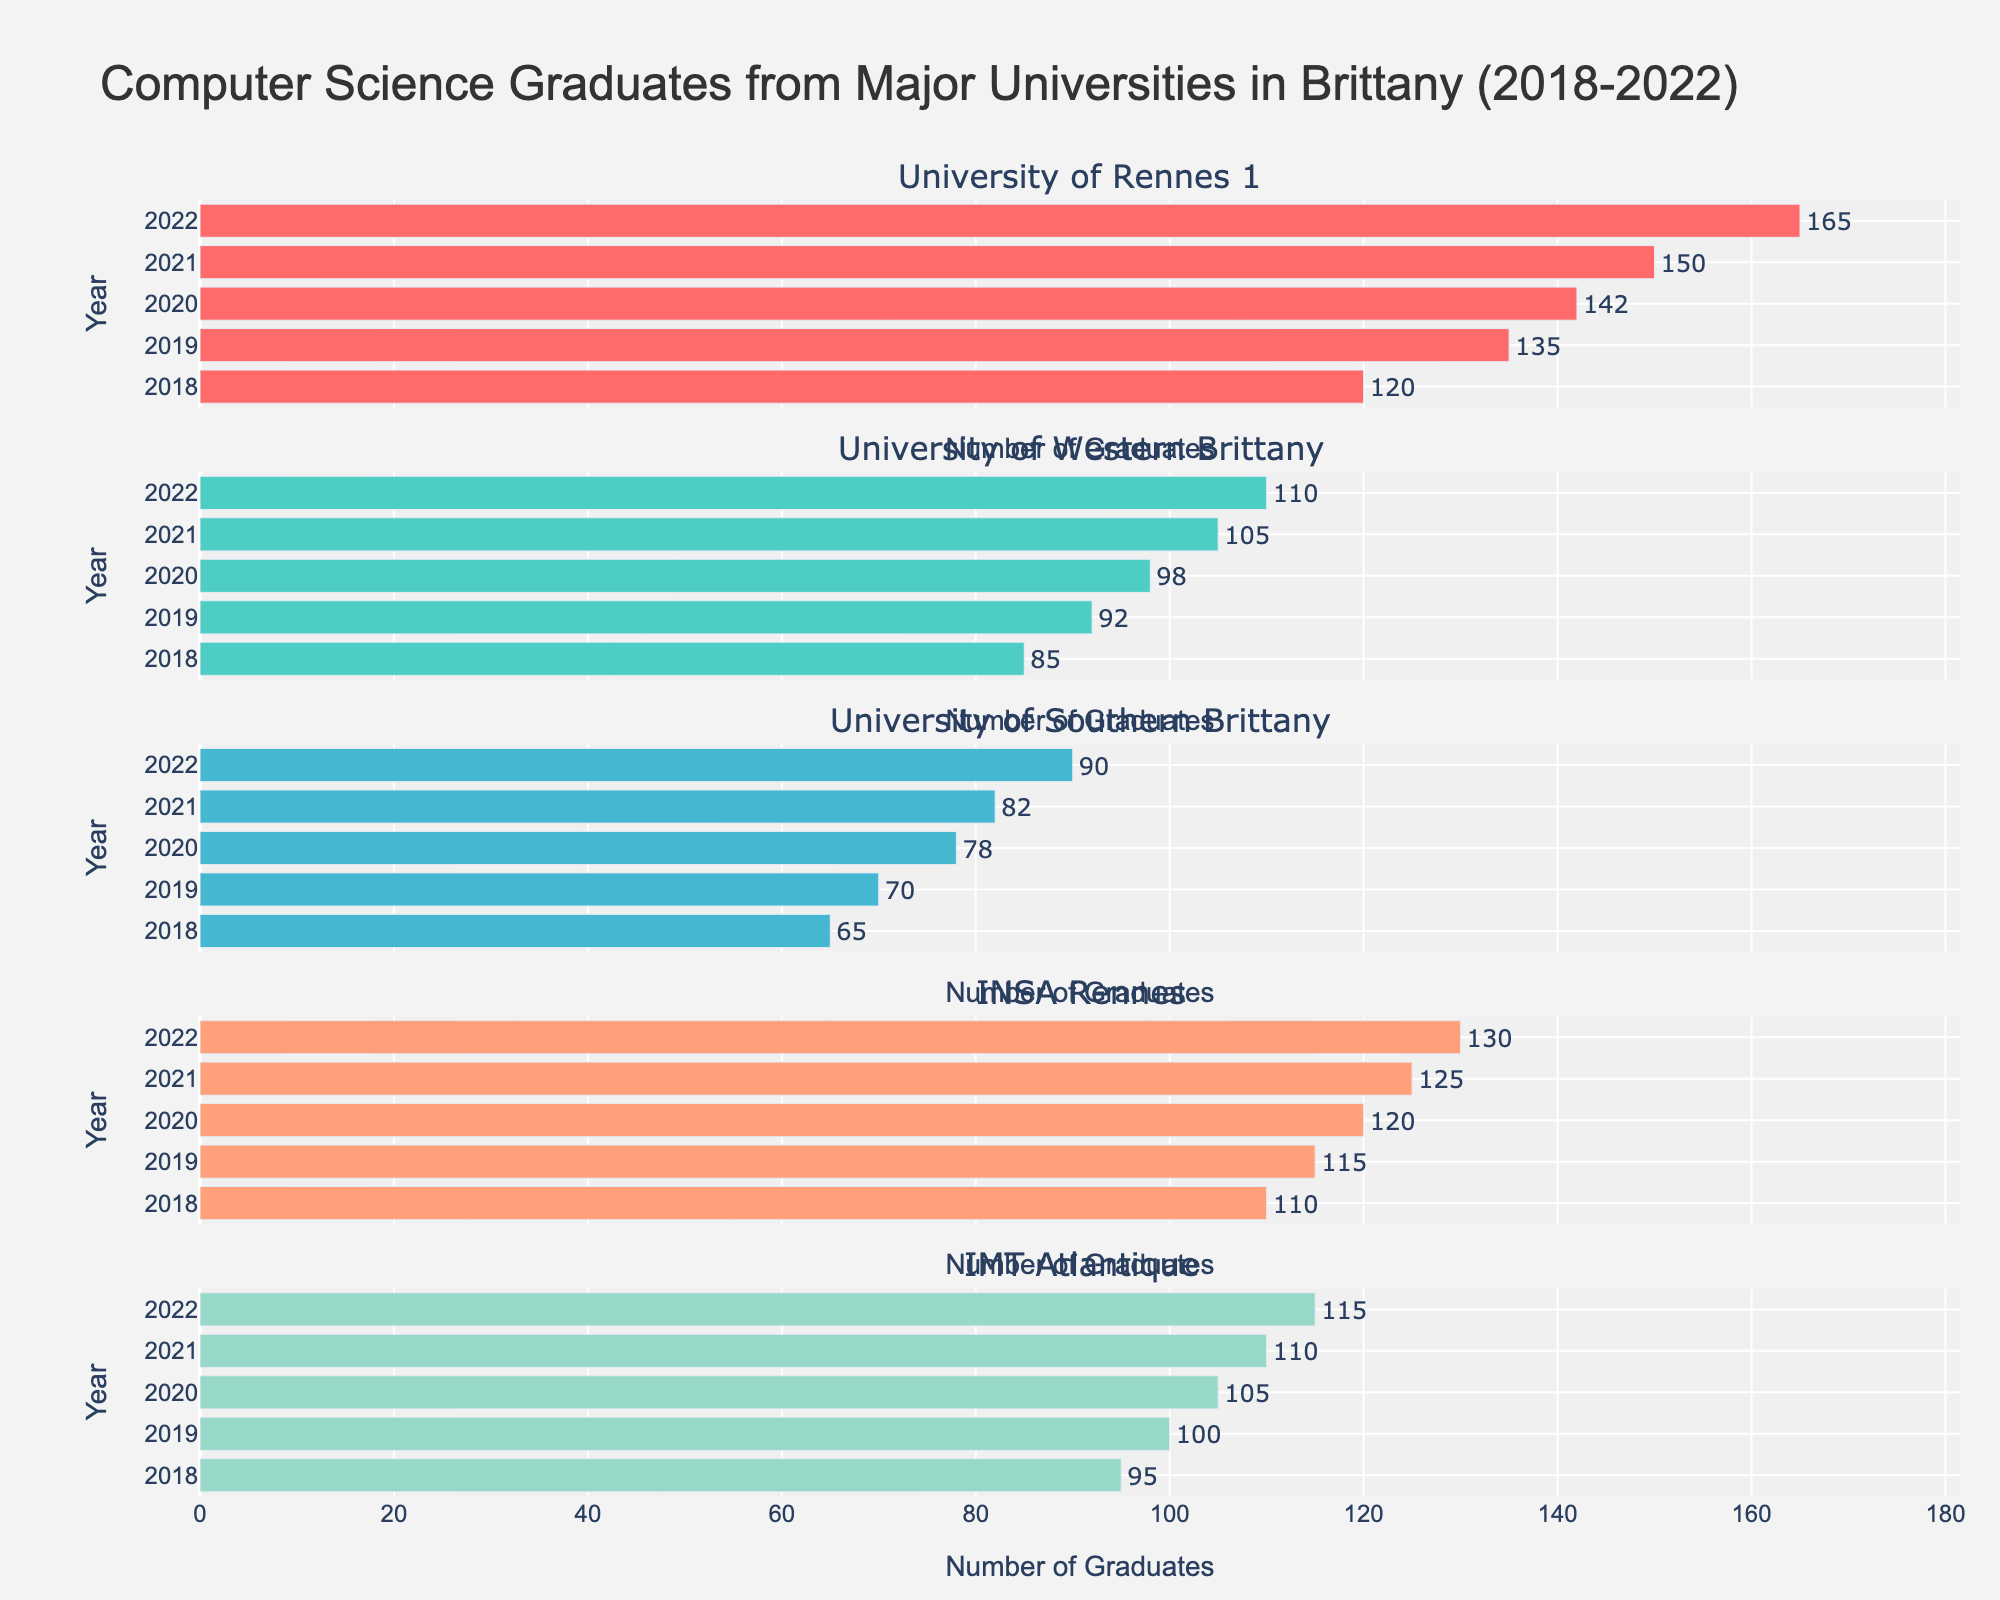how many universities are displayed in the figure? The subplot titles indicate the number of universities, and there are five subplot titles showing the different universities in Brittany.
Answer: 5 What is the main title of the figure? The main title is displayed at the top of the figure, providing a summary of the visual information being represented.
Answer: Computer Science Graduates from Major Universities in Brittany (2018-2022) Which university had the most computer science graduates in 2022? According to the longest bar for the year 2022 across all subplots, the University of Rennes 1 had the highest number with 165 graduates.
Answer: University of Rennes 1 How has the number of computer science graduates at the University of Western Brittany changed from 2018 to 2022? By observing the length of the bars for each year in the subplot for the University of Western Brittany, it increases from 85 in 2018 to 110 in 2022.
Answer: Increased from 85 to 110 Which universities had an increase in the number of computer science graduates every year from 2018 to 2022? By examining each subplot, all universities show bars increasing each year, but verifying each one specifically, University of Rennes 1, University of Western Brittany, University of Southern Brittany, INSA Rennes, and IMT Atlantique all had a consistent increase each year.
Answer: All universities What is the average number of graduates per year for INSA Rennes over the five years? Observing INSA Rennes subplot, the number of graduates each year are 110, 115, 120, 125, and 130. The average can be calculated as (110+115+120+125+130)/5.
Answer: 120 Compared to the University of Southern Brittany, how many more graduates did the University of Rennes 1 have in 2021? From the respective subplots, University of Rennes 1 had 150 graduates in 2021, and the University of Southern Brittany had 82 graduates. The difference is 150 - 82.
Answer: 68 Which university showed the least increase in graduates from 2021 to 2022? Observing the difference in bar lengths between these two years for each subplot, INSA Rennes showed a minimal increase from 125 to 130, which is an increase of 5 graduates.
Answer: INSA Rennes What is the total number of graduates for IMT Atlantique over the five years? From the IMT Atlantique subplot, the number of graduates each year are 95, 100, 105, 110, and 115. The total is the sum of these values.
Answer: 525 Which year had the highest number of total CS graduates across all universities? By summing the graduates from each university for each year: for 2022, the sum is 165 + 110 + 90 + 130 + 115 = 610, which is the highest compared to other years.
Answer: 2022 